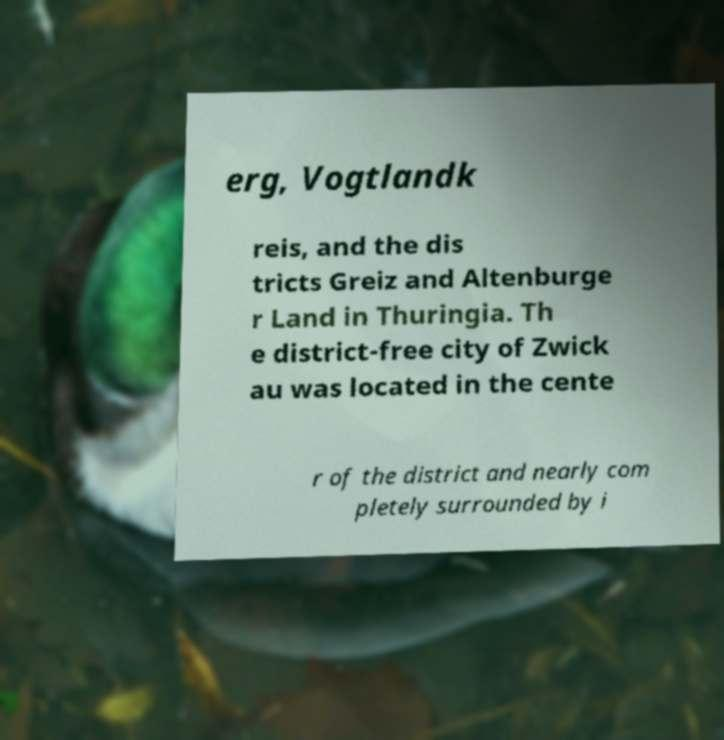Please read and relay the text visible in this image. What does it say? erg, Vogtlandk reis, and the dis tricts Greiz and Altenburge r Land in Thuringia. Th e district-free city of Zwick au was located in the cente r of the district and nearly com pletely surrounded by i 